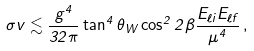<formula> <loc_0><loc_0><loc_500><loc_500>\sigma v \lesssim \frac { g ^ { 4 } } { 3 2 \pi } \tan ^ { 4 } \theta _ { W } \cos ^ { 2 } 2 \beta \frac { E _ { \ell i } E _ { \ell f } } { \mu ^ { 4 } } \, ,</formula> 